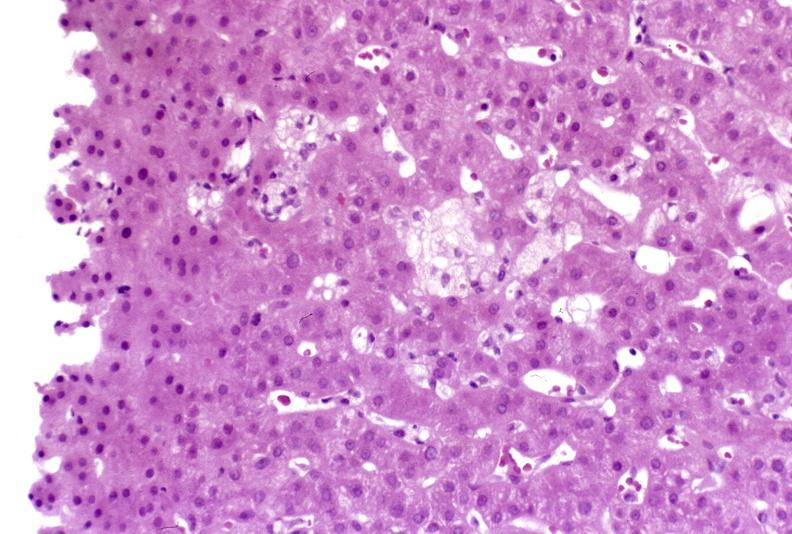what is present?
Answer the question using a single word or phrase. Liver 